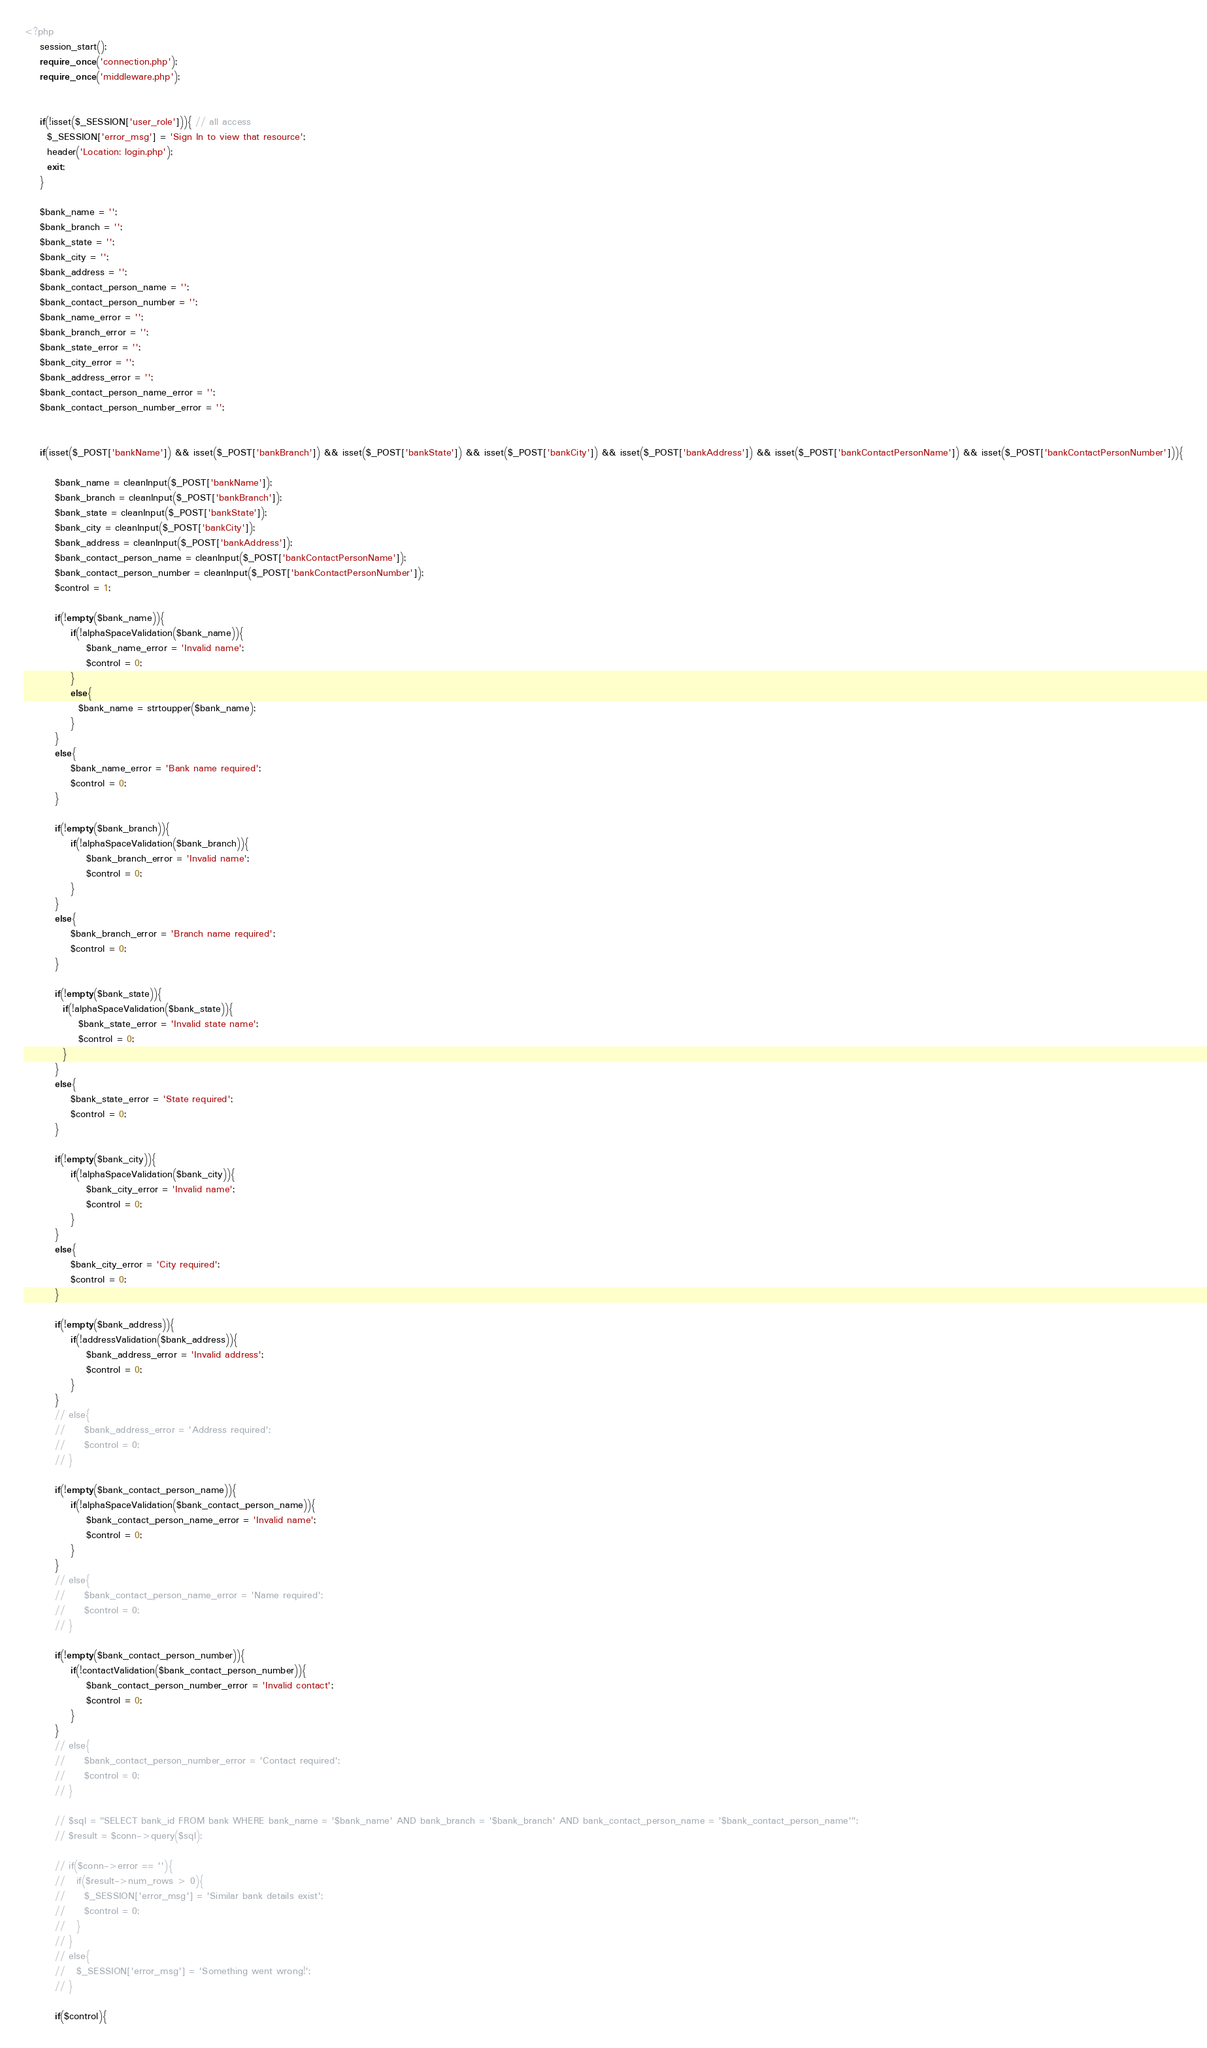<code> <loc_0><loc_0><loc_500><loc_500><_PHP_><?php 
    session_start();
    require_once('connection.php');
    require_once('middleware.php');
    

    if(!isset($_SESSION['user_role'])){ // all access
      $_SESSION['error_msg'] = 'Sign In to view that resource';
      header('Location: login.php');
      exit;
    }

    $bank_name = '';
    $bank_branch = '';
    $bank_state = '';
    $bank_city = '';
    $bank_address = '';
    $bank_contact_person_name = '';
    $bank_contact_person_number = '';
    $bank_name_error = '';
    $bank_branch_error = '';
    $bank_state_error = '';
    $bank_city_error = '';
    $bank_address_error = '';
    $bank_contact_person_name_error = '';
    $bank_contact_person_number_error = '';
    

    if(isset($_POST['bankName']) && isset($_POST['bankBranch']) && isset($_POST['bankState']) && isset($_POST['bankCity']) && isset($_POST['bankAddress']) && isset($_POST['bankContactPersonName']) && isset($_POST['bankContactPersonNumber'])){

        $bank_name = cleanInput($_POST['bankName']);
        $bank_branch = cleanInput($_POST['bankBranch']);
        $bank_state = cleanInput($_POST['bankState']);
        $bank_city = cleanInput($_POST['bankCity']);
        $bank_address = cleanInput($_POST['bankAddress']);
        $bank_contact_person_name = cleanInput($_POST['bankContactPersonName']);
        $bank_contact_person_number = cleanInput($_POST['bankContactPersonNumber']);
        $control = 1;

        if(!empty($bank_name)){
            if(!alphaSpaceValidation($bank_name)){
                $bank_name_error = 'Invalid name';
                $control = 0;
            }
            else{
              $bank_name = strtoupper($bank_name);
            }
        }
        else{
            $bank_name_error = 'Bank name required';
            $control = 0;
        }

        if(!empty($bank_branch)){
            if(!alphaSpaceValidation($bank_branch)){
                $bank_branch_error = 'Invalid name';
                $control = 0;
            }
        }
        else{
            $bank_branch_error = 'Branch name required';
            $control = 0;
        }
        
        if(!empty($bank_state)){
          if(!alphaSpaceValidation($bank_state)){
              $bank_state_error = 'Invalid state name';
              $control = 0;
          }
        }
        else{
            $bank_state_error = 'State required';
            $control = 0;
        }

        if(!empty($bank_city)){
            if(!alphaSpaceValidation($bank_city)){
                $bank_city_error = 'Invalid name';
                $control = 0;
            }
        }
        else{
            $bank_city_error = 'City required';
            $control = 0;
        }

        if(!empty($bank_address)){
            if(!addressValidation($bank_address)){
                $bank_address_error = 'Invalid address';
                $control = 0;
            }
        }
        // else{
        //     $bank_address_error = 'Address required';
        //     $control = 0;
        // }

        if(!empty($bank_contact_person_name)){
            if(!alphaSpaceValidation($bank_contact_person_name)){
                $bank_contact_person_name_error = 'Invalid name';
                $control = 0;
            }
        }
        // else{
        //     $bank_contact_person_name_error = 'Name required';
        //     $control = 0;
        // }

        if(!empty($bank_contact_person_number)){
            if(!contactValidation($bank_contact_person_number)){
                $bank_contact_person_number_error = 'Invalid contact';
                $control = 0;
            }
        }
        // else{
        //     $bank_contact_person_number_error = 'Contact required';
        //     $control = 0;
        // }
        
        // $sql = "SELECT bank_id FROM bank WHERE bank_name = '$bank_name' AND bank_branch = '$bank_branch' AND bank_contact_person_name = '$bank_contact_person_name'";
        // $result = $conn->query($sql);

        // if($conn->error == ''){
        //   if($result->num_rows > 0){
        //     $_SESSION['error_msg'] = 'Similar bank details exist';
        //     $control = 0;
        //   }
        // }
        // else{
        //   $_SESSION['error_msg'] = 'Something went wrong!';
        // }

        if($control){</code> 